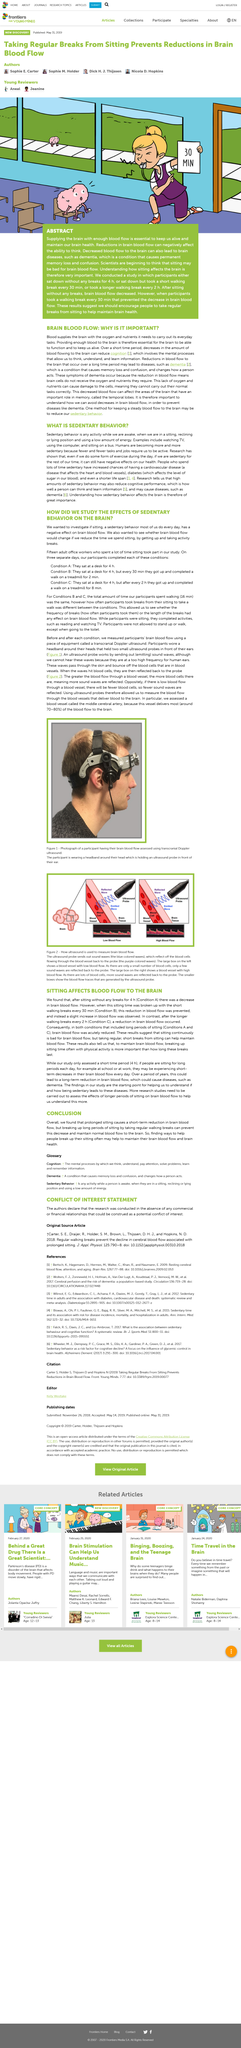Identify some key points in this picture. The image depicts a participant undergoing a procedure to assess blood flow in their brain using transcranial Doppler ultrasound. The results of the study indicated that prolonged sitting can negatively affect brain blood flow, but taking regular breaks can help maintain flow. A lack of oxygen and nutrients can cause damage to the cells, leading to a range of negative effects on the body. Long-term sedentary behavior can lead to a reduction in brain blood flow and increase the risk of diseases such as dementia, as suggested by the findings of a recent study. An ultrasound probe works by emitting sound waves and detecting the returning echoes to form an image of internal structures. 